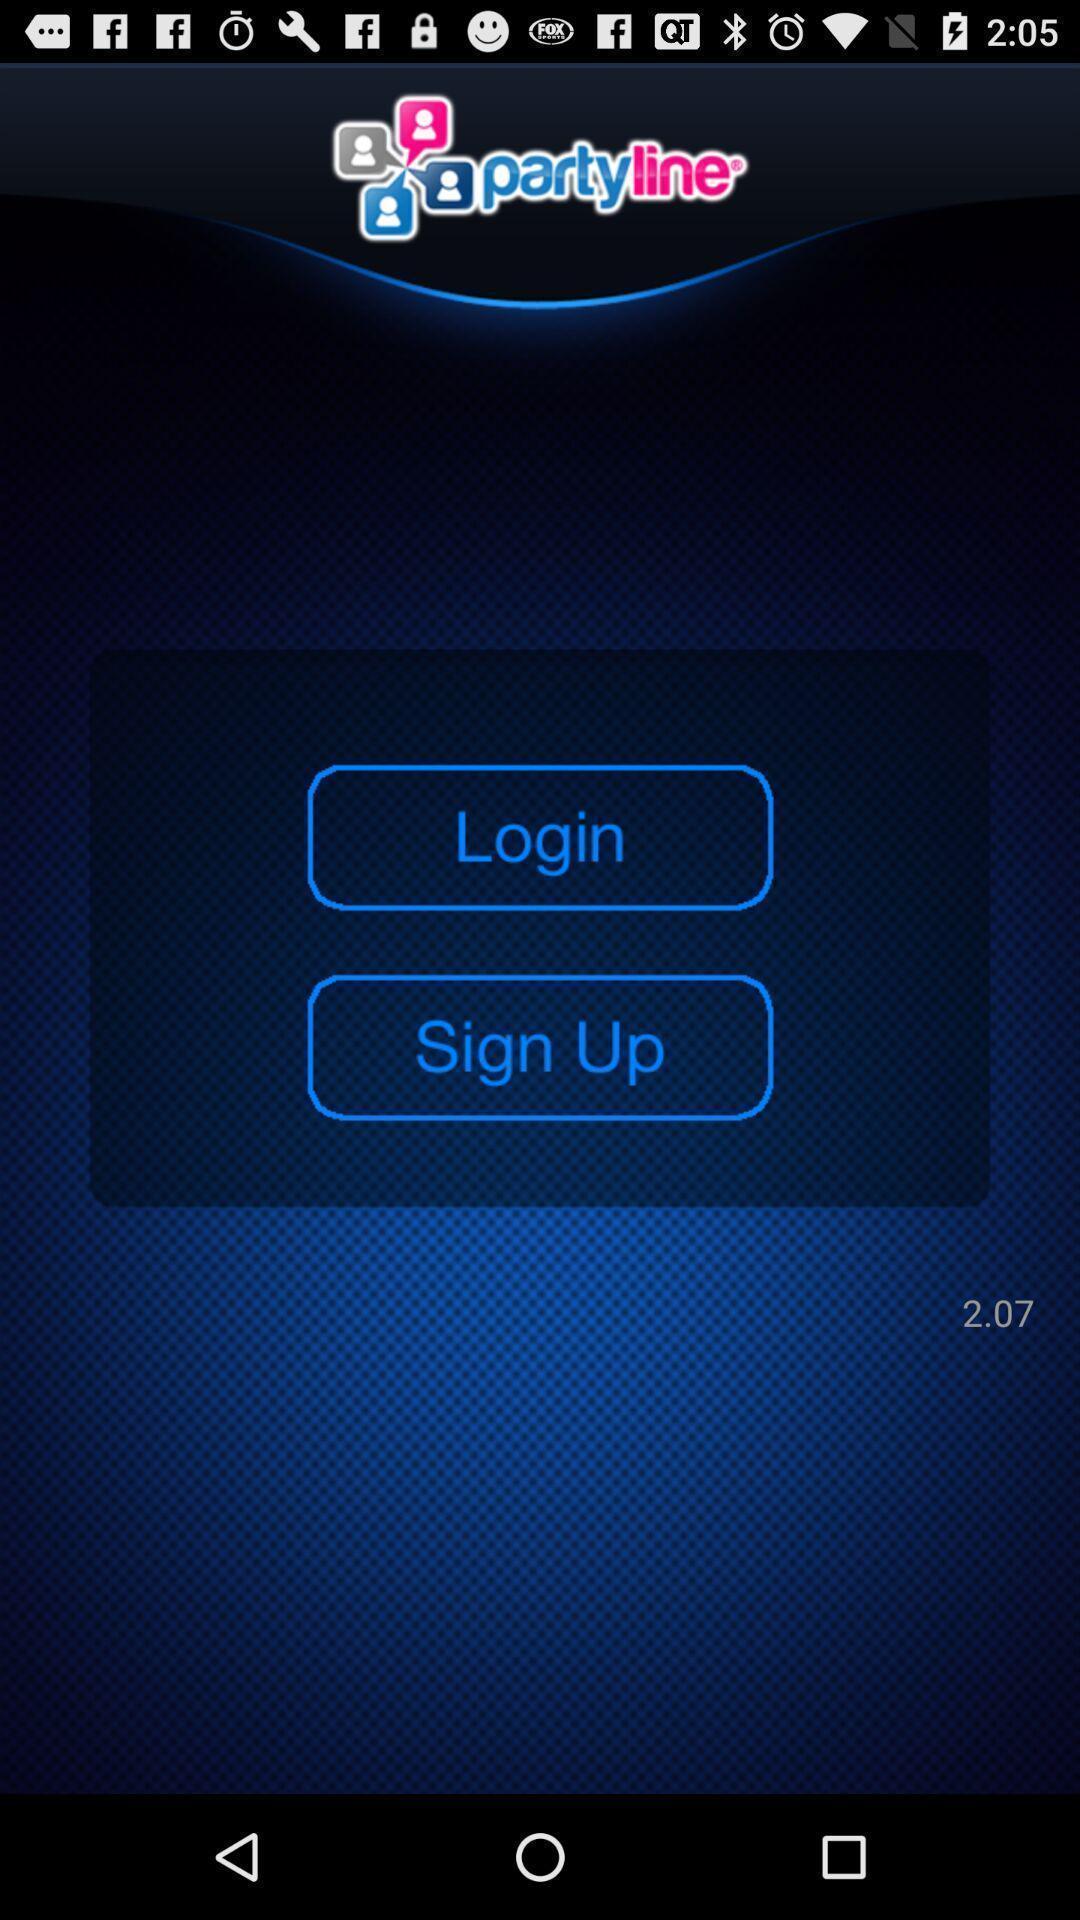What details can you identify in this image? Page displaying login and sign up options. 